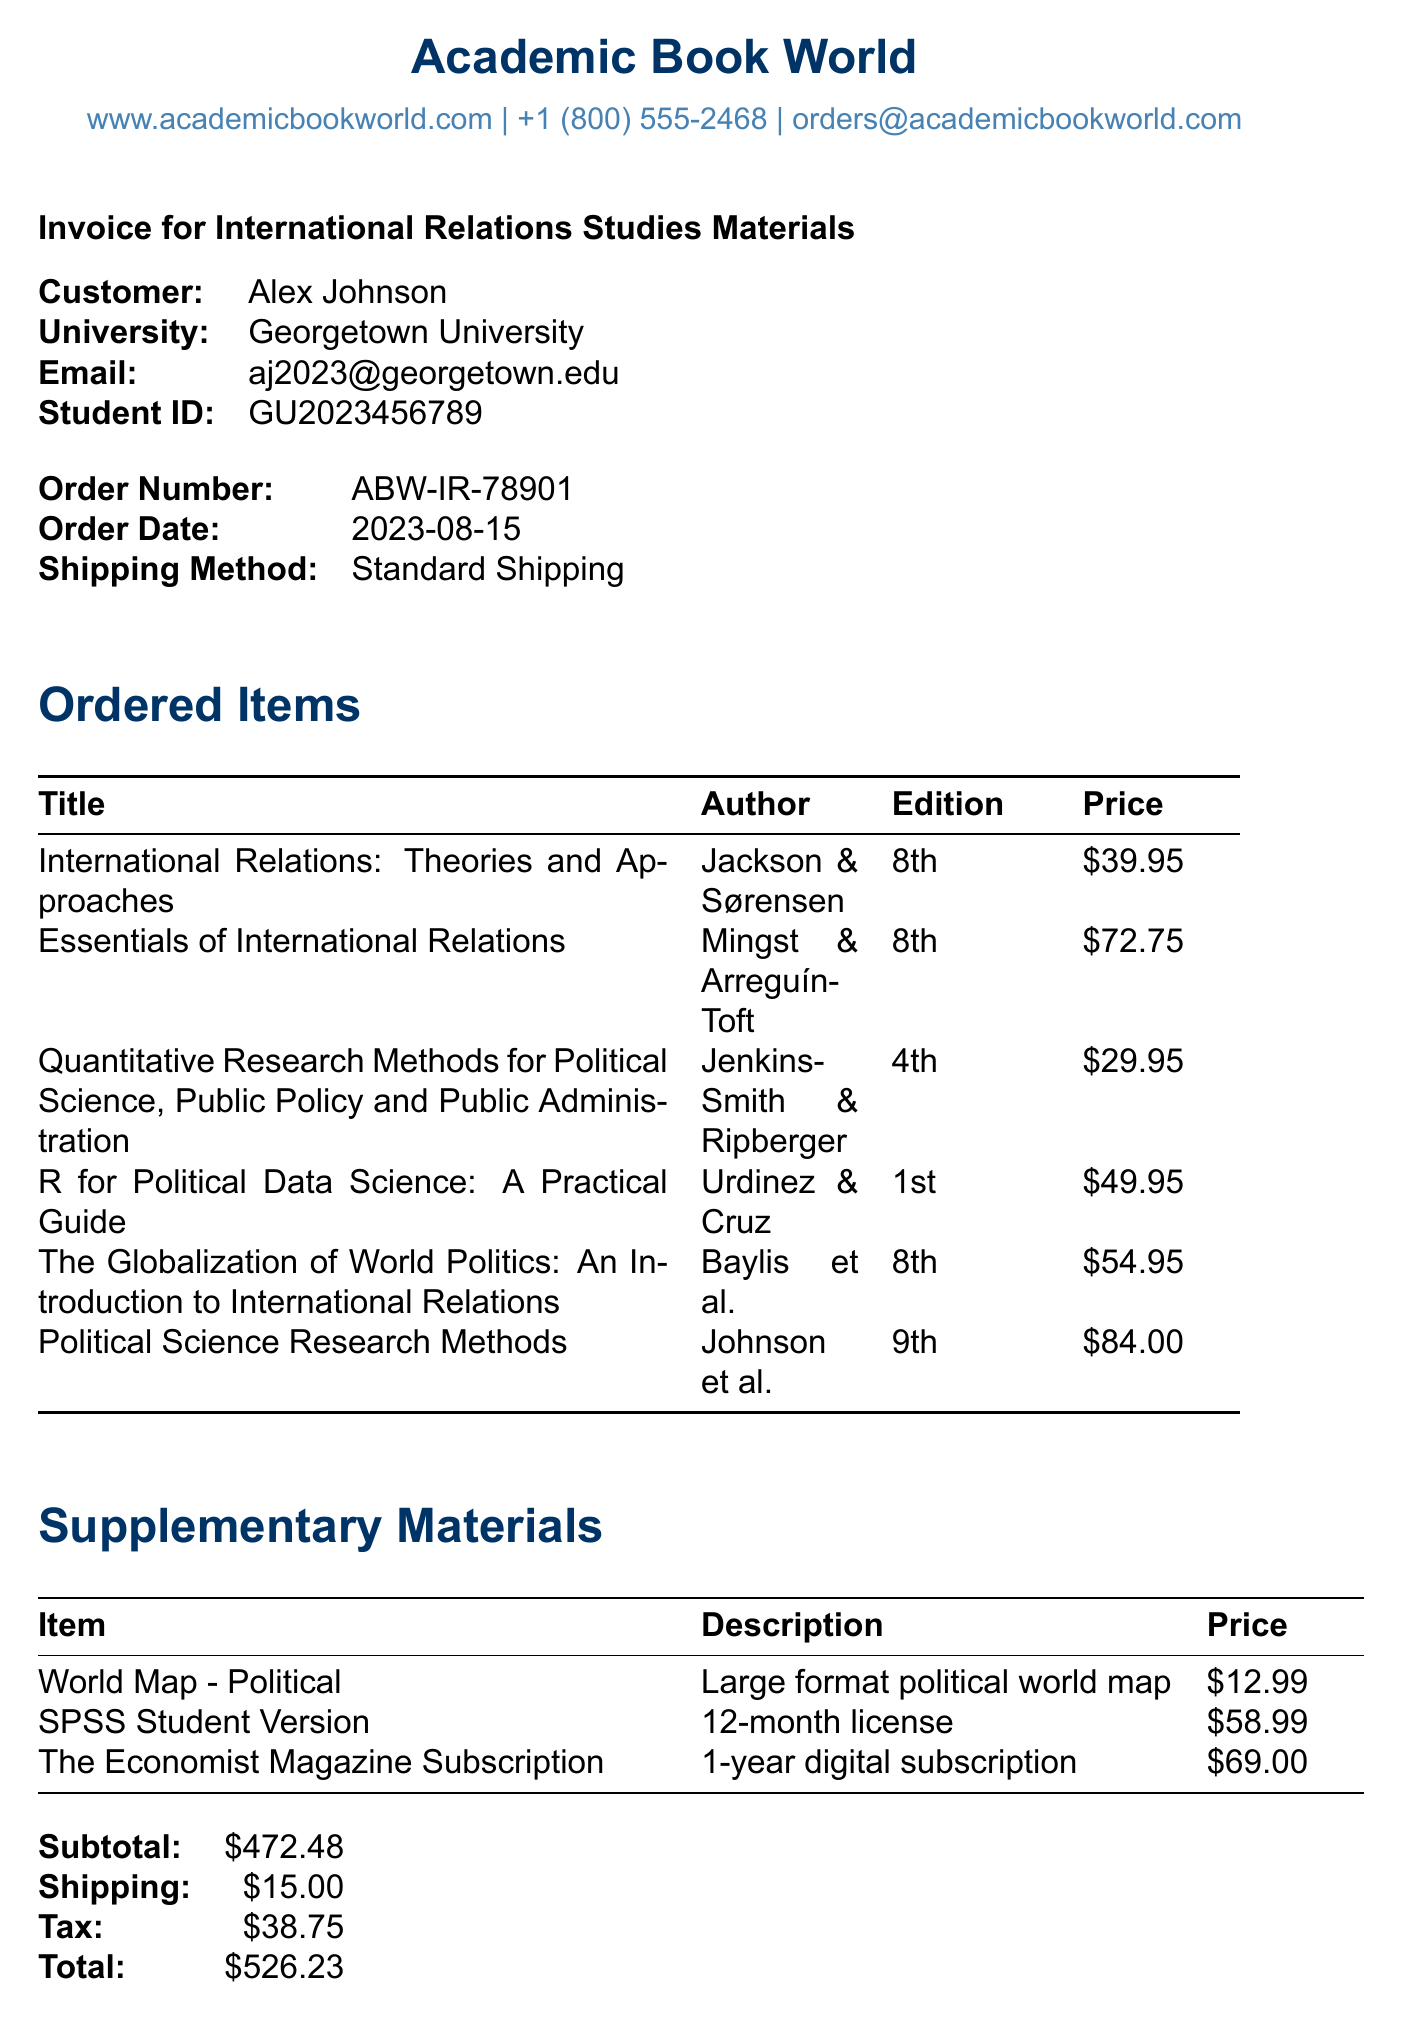what is the name of the retailer? The retailer's name is provided at the top of the invoice as the source of the purchase.
Answer: Academic Book World what is the total amount billed? The total amount billed is shown in the totals section as the final amount to be paid.
Answer: $526.23 who is the author of "International Relations: Theories and Approaches"? The author is listed in the ordered items section, providing the specific person(s) responsible for the book.
Answer: Robert Jackson and Georg Sørensen what is the order date? The order date is specified in the order details section of the invoice.
Answer: 2023-08-15 how many books are listed in the ordered items? Counting the items in the ordered items section will give the total number of books purchased.
Answer: 6 what is the description of the supplementary material "The Economist Magazine Subscription"? The description is provided to give context about what the supplementary material entails.
Answer: 1-year digital subscription what payment method was used? The payment method used is stated clearly in the payment section of the invoice.
Answer: Credit Card how much was charged for shipping? The shipping cost is clearly listed in the totals section, providing transparency regarding additional fees.
Answer: $15.00 what is the subtotal before tax and shipping? The subtotal is detailed in the totals section, representing the sum of all items without additional fees.
Answer: $472.48 